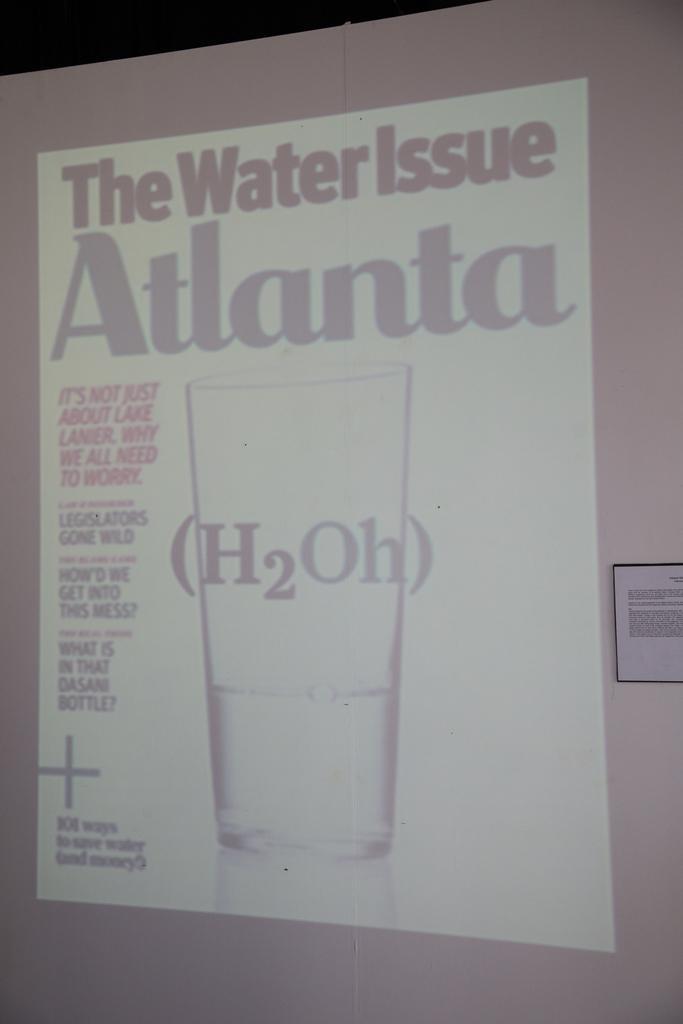How would you summarize this image in a sentence or two? In this picture we can see a projector screen and on the screen we can see a glass of water. There is something written. Beside to the screen there is a board. 